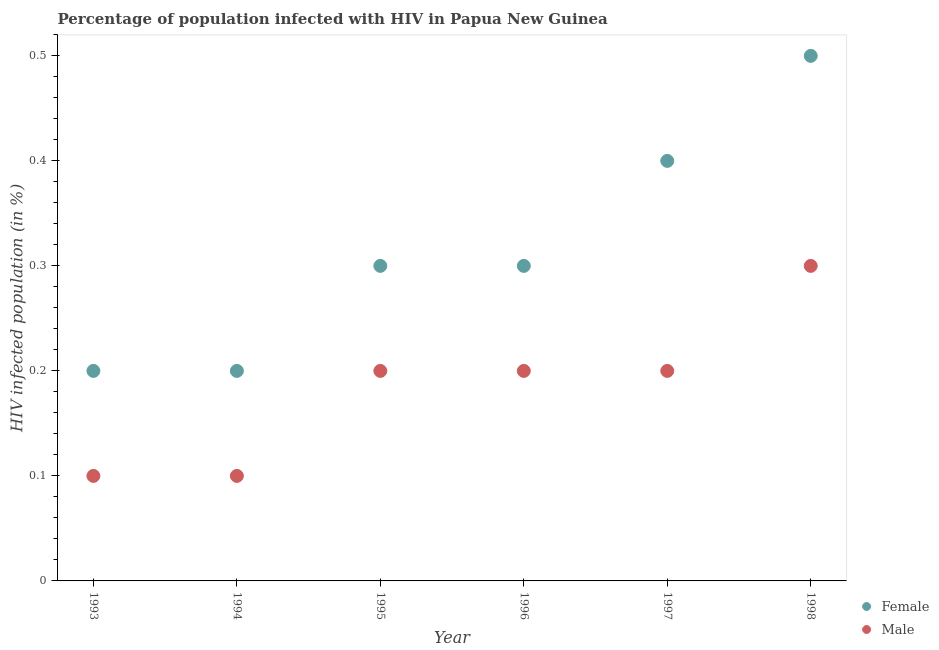Is the number of dotlines equal to the number of legend labels?
Your response must be concise. Yes. What is the percentage of males who are infected with hiv in 1996?
Ensure brevity in your answer.  0.2. Across all years, what is the maximum percentage of males who are infected with hiv?
Keep it short and to the point. 0.3. Across all years, what is the minimum percentage of males who are infected with hiv?
Keep it short and to the point. 0.1. In which year was the percentage of females who are infected with hiv maximum?
Ensure brevity in your answer.  1998. In which year was the percentage of males who are infected with hiv minimum?
Ensure brevity in your answer.  1993. What is the difference between the percentage of females who are infected with hiv in 1994 and that in 1995?
Provide a succinct answer. -0.1. What is the average percentage of females who are infected with hiv per year?
Your response must be concise. 0.32. In how many years, is the percentage of males who are infected with hiv greater than 0.16 %?
Provide a succinct answer. 4. What is the ratio of the percentage of females who are infected with hiv in 1995 to that in 1996?
Your answer should be very brief. 1. Is the percentage of males who are infected with hiv in 1995 less than that in 1997?
Your answer should be very brief. No. What is the difference between the highest and the second highest percentage of females who are infected with hiv?
Provide a succinct answer. 0.1. What is the difference between the highest and the lowest percentage of males who are infected with hiv?
Offer a very short reply. 0.2. In how many years, is the percentage of males who are infected with hiv greater than the average percentage of males who are infected with hiv taken over all years?
Offer a very short reply. 4. Is the percentage of males who are infected with hiv strictly greater than the percentage of females who are infected with hiv over the years?
Offer a very short reply. No. How many years are there in the graph?
Your response must be concise. 6. Are the values on the major ticks of Y-axis written in scientific E-notation?
Ensure brevity in your answer.  No. Does the graph contain any zero values?
Provide a succinct answer. No. Does the graph contain grids?
Make the answer very short. No. Where does the legend appear in the graph?
Provide a short and direct response. Bottom right. How many legend labels are there?
Your response must be concise. 2. What is the title of the graph?
Offer a terse response. Percentage of population infected with HIV in Papua New Guinea. Does "Female population" appear as one of the legend labels in the graph?
Provide a succinct answer. No. What is the label or title of the X-axis?
Your answer should be very brief. Year. What is the label or title of the Y-axis?
Offer a very short reply. HIV infected population (in %). What is the HIV infected population (in %) in Female in 1993?
Your answer should be very brief. 0.2. What is the HIV infected population (in %) of Male in 1993?
Ensure brevity in your answer.  0.1. What is the HIV infected population (in %) of Female in 1994?
Offer a very short reply. 0.2. What is the HIV infected population (in %) of Female in 1995?
Offer a very short reply. 0.3. What is the HIV infected population (in %) of Female in 1997?
Offer a very short reply. 0.4. What is the HIV infected population (in %) of Male in 1997?
Offer a terse response. 0.2. Across all years, what is the maximum HIV infected population (in %) of Female?
Offer a very short reply. 0.5. Across all years, what is the maximum HIV infected population (in %) of Male?
Provide a succinct answer. 0.3. Across all years, what is the minimum HIV infected population (in %) of Male?
Provide a succinct answer. 0.1. What is the total HIV infected population (in %) in Female in the graph?
Keep it short and to the point. 1.9. What is the difference between the HIV infected population (in %) of Female in 1993 and that in 1994?
Your answer should be compact. 0. What is the difference between the HIV infected population (in %) in Male in 1993 and that in 1995?
Your response must be concise. -0.1. What is the difference between the HIV infected population (in %) in Female in 1993 and that in 1996?
Provide a succinct answer. -0.1. What is the difference between the HIV infected population (in %) of Female in 1993 and that in 1997?
Keep it short and to the point. -0.2. What is the difference between the HIV infected population (in %) of Female in 1993 and that in 1998?
Ensure brevity in your answer.  -0.3. What is the difference between the HIV infected population (in %) of Male in 1993 and that in 1998?
Provide a succinct answer. -0.2. What is the difference between the HIV infected population (in %) in Female in 1994 and that in 1996?
Provide a succinct answer. -0.1. What is the difference between the HIV infected population (in %) of Male in 1994 and that in 1997?
Provide a succinct answer. -0.1. What is the difference between the HIV infected population (in %) in Male in 1994 and that in 1998?
Your answer should be very brief. -0.2. What is the difference between the HIV infected population (in %) of Female in 1995 and that in 1997?
Keep it short and to the point. -0.1. What is the difference between the HIV infected population (in %) of Female in 1995 and that in 1998?
Provide a succinct answer. -0.2. What is the difference between the HIV infected population (in %) of Male in 1995 and that in 1998?
Ensure brevity in your answer.  -0.1. What is the difference between the HIV infected population (in %) in Female in 1996 and that in 1997?
Keep it short and to the point. -0.1. What is the difference between the HIV infected population (in %) of Male in 1996 and that in 1997?
Provide a short and direct response. 0. What is the difference between the HIV infected population (in %) of Female in 1996 and that in 1998?
Give a very brief answer. -0.2. What is the difference between the HIV infected population (in %) of Female in 1997 and that in 1998?
Provide a short and direct response. -0.1. What is the difference between the HIV infected population (in %) of Female in 1993 and the HIV infected population (in %) of Male in 1996?
Give a very brief answer. 0. What is the difference between the HIV infected population (in %) in Female in 1993 and the HIV infected population (in %) in Male in 1997?
Make the answer very short. 0. What is the difference between the HIV infected population (in %) in Female in 1994 and the HIV infected population (in %) in Male in 1996?
Provide a succinct answer. 0. What is the difference between the HIV infected population (in %) in Female in 1994 and the HIV infected population (in %) in Male in 1997?
Give a very brief answer. 0. What is the difference between the HIV infected population (in %) of Female in 1996 and the HIV infected population (in %) of Male in 1998?
Give a very brief answer. 0. What is the average HIV infected population (in %) in Female per year?
Your answer should be very brief. 0.32. What is the average HIV infected population (in %) of Male per year?
Make the answer very short. 0.18. In the year 1993, what is the difference between the HIV infected population (in %) in Female and HIV infected population (in %) in Male?
Keep it short and to the point. 0.1. In the year 1998, what is the difference between the HIV infected population (in %) in Female and HIV infected population (in %) in Male?
Offer a very short reply. 0.2. What is the ratio of the HIV infected population (in %) in Male in 1993 to that in 1994?
Provide a succinct answer. 1. What is the ratio of the HIV infected population (in %) in Female in 1993 to that in 1997?
Your response must be concise. 0.5. What is the ratio of the HIV infected population (in %) of Male in 1993 to that in 1997?
Ensure brevity in your answer.  0.5. What is the ratio of the HIV infected population (in %) of Male in 1994 to that in 1995?
Make the answer very short. 0.5. What is the ratio of the HIV infected population (in %) in Female in 1994 to that in 1996?
Offer a very short reply. 0.67. What is the ratio of the HIV infected population (in %) of Male in 1994 to that in 1997?
Give a very brief answer. 0.5. What is the ratio of the HIV infected population (in %) in Male in 1994 to that in 1998?
Keep it short and to the point. 0.33. What is the ratio of the HIV infected population (in %) of Male in 1995 to that in 1996?
Ensure brevity in your answer.  1. What is the ratio of the HIV infected population (in %) of Female in 1995 to that in 1997?
Make the answer very short. 0.75. What is the ratio of the HIV infected population (in %) in Male in 1995 to that in 1997?
Ensure brevity in your answer.  1. What is the ratio of the HIV infected population (in %) of Female in 1996 to that in 1998?
Keep it short and to the point. 0.6. What is the ratio of the HIV infected population (in %) in Male in 1996 to that in 1998?
Offer a very short reply. 0.67. What is the ratio of the HIV infected population (in %) in Female in 1997 to that in 1998?
Your response must be concise. 0.8. What is the ratio of the HIV infected population (in %) of Male in 1997 to that in 1998?
Your response must be concise. 0.67. What is the difference between the highest and the second highest HIV infected population (in %) in Female?
Offer a very short reply. 0.1. What is the difference between the highest and the lowest HIV infected population (in %) in Male?
Provide a short and direct response. 0.2. 